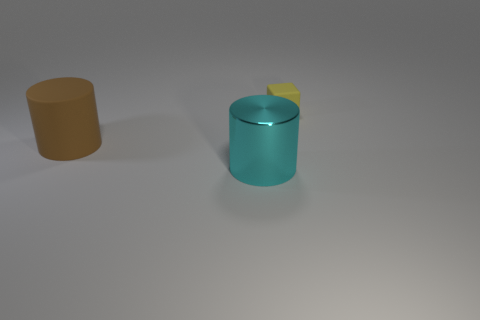Is there anything else that is the same size as the metallic thing?
Offer a very short reply. Yes. Are there more big shiny cylinders that are in front of the rubber cylinder than small yellow metallic cylinders?
Give a very brief answer. Yes. There is a large thing behind the cyan metallic cylinder to the right of the matte thing in front of the tiny matte cube; what is its shape?
Keep it short and to the point. Cylinder. There is a cylinder on the right side of the brown cylinder; is it the same size as the big brown thing?
Offer a terse response. Yes. The thing that is both to the right of the big brown matte object and on the left side of the tiny rubber cube has what shape?
Offer a terse response. Cylinder. There is a large cylinder that is in front of the thing that is to the left of the cylinder in front of the large rubber cylinder; what is its color?
Offer a very short reply. Cyan. The other thing that is the same shape as the brown matte object is what color?
Ensure brevity in your answer.  Cyan. Are there the same number of tiny blocks that are to the right of the brown rubber cylinder and rubber cylinders?
Give a very brief answer. Yes. How many balls are large purple matte objects or cyan things?
Your response must be concise. 0. What is the color of the big cylinder that is the same material as the block?
Offer a terse response. Brown. 